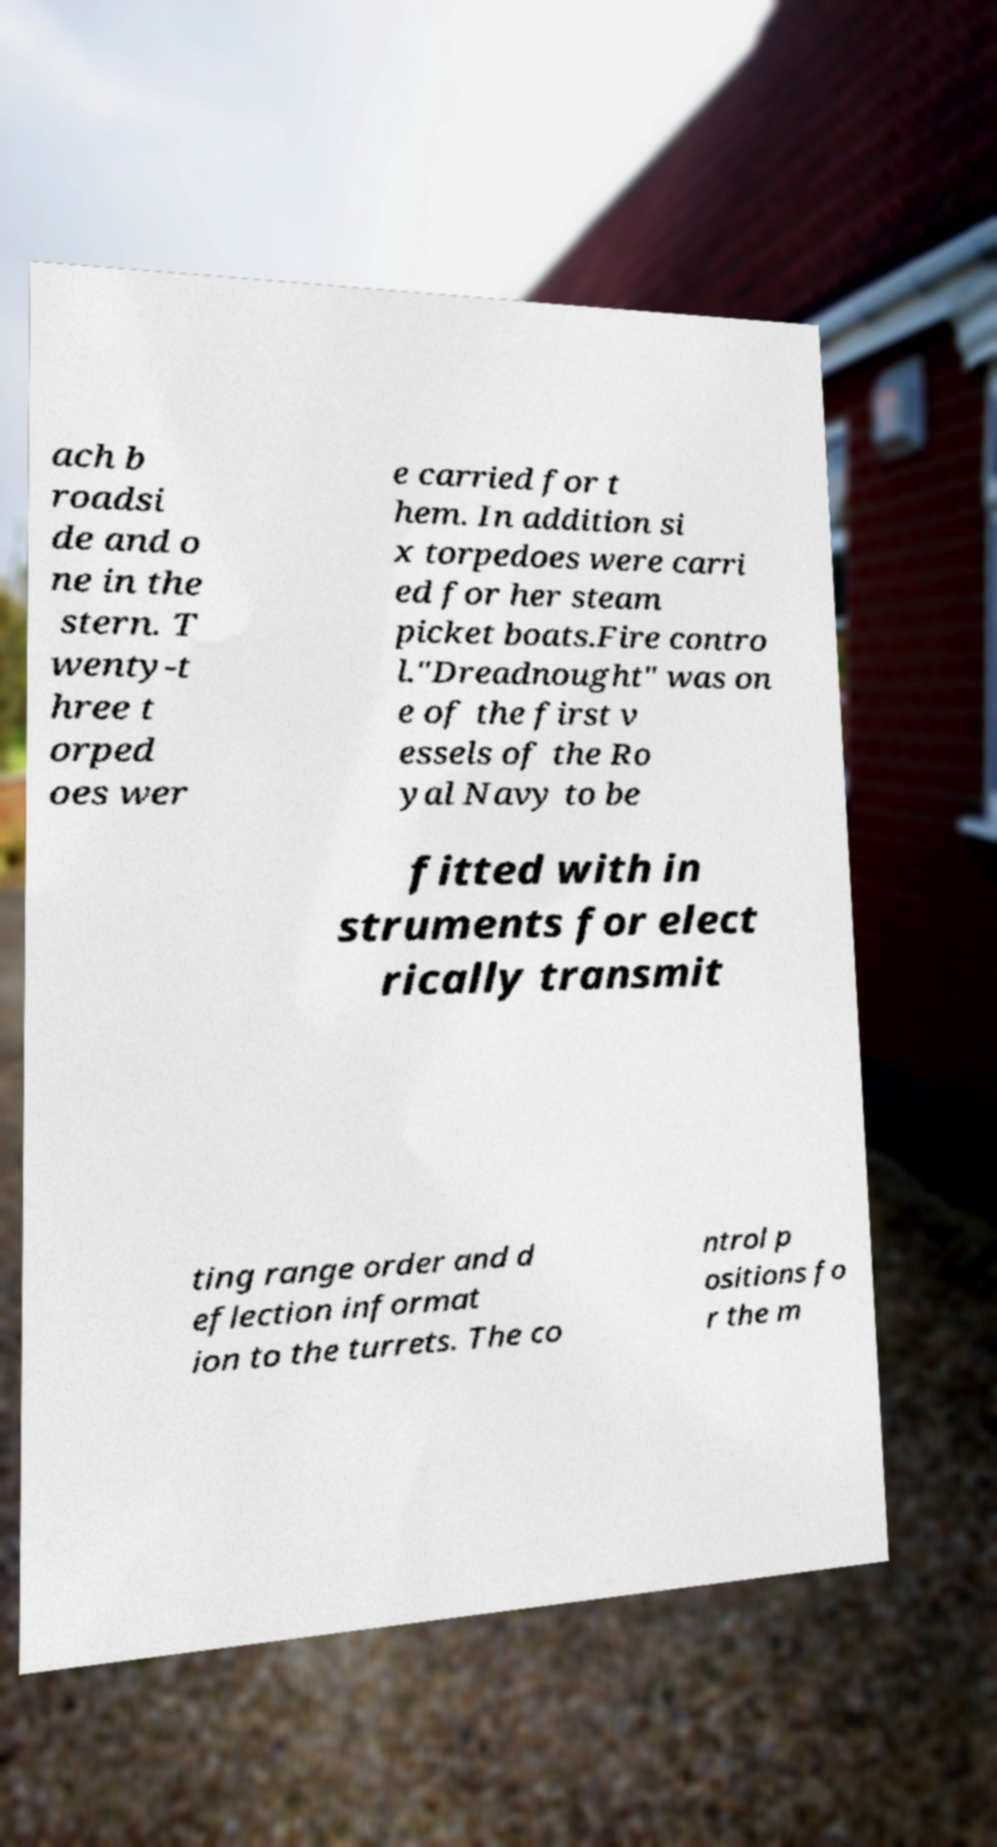I need the written content from this picture converted into text. Can you do that? ach b roadsi de and o ne in the stern. T wenty-t hree t orped oes wer e carried for t hem. In addition si x torpedoes were carri ed for her steam picket boats.Fire contro l."Dreadnought" was on e of the first v essels of the Ro yal Navy to be fitted with in struments for elect rically transmit ting range order and d eflection informat ion to the turrets. The co ntrol p ositions fo r the m 